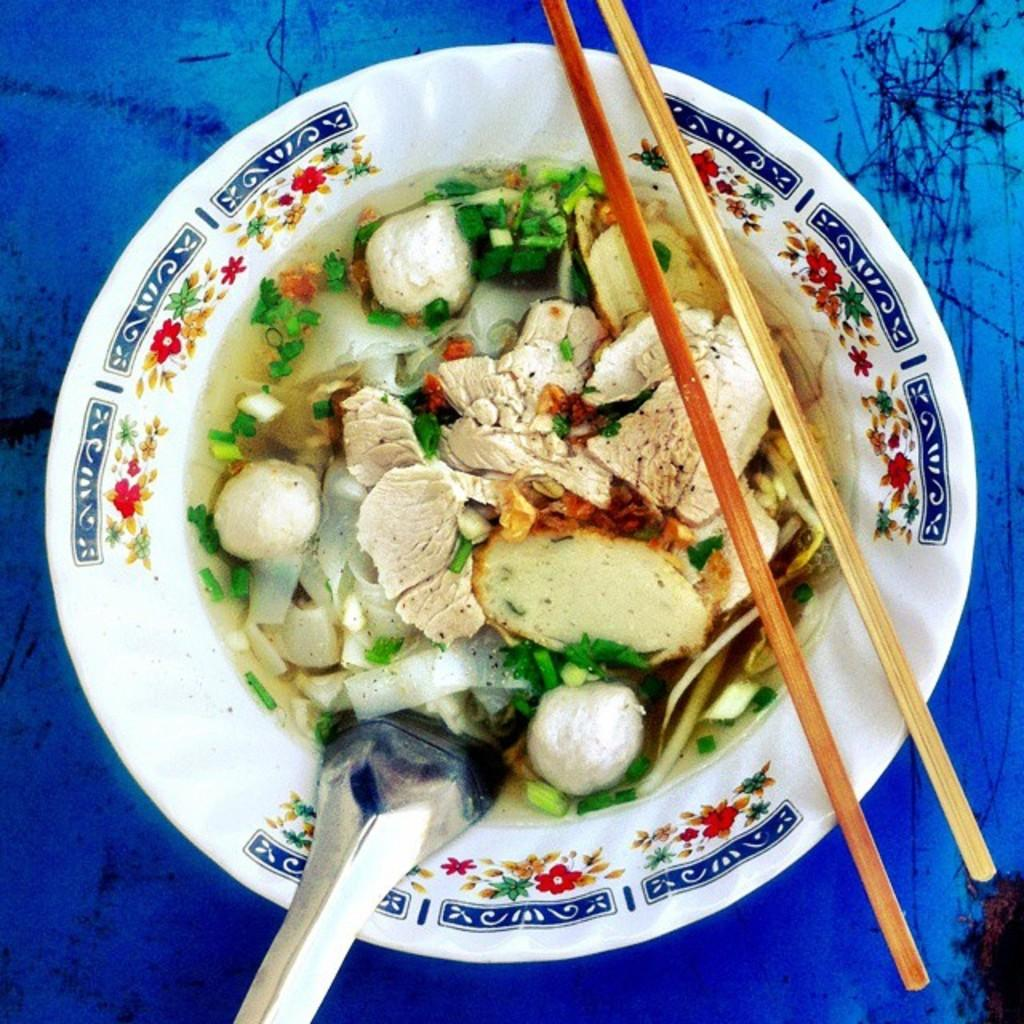What is in the bowl that is visible in the image? There is a bowl with food items in the image. What utensil is visible in the image? There is a spoon visible in the image. What type of humor can be observed in the image? There is no humor present in the image; it is a simple image of a bowl with food items and a spoon. 